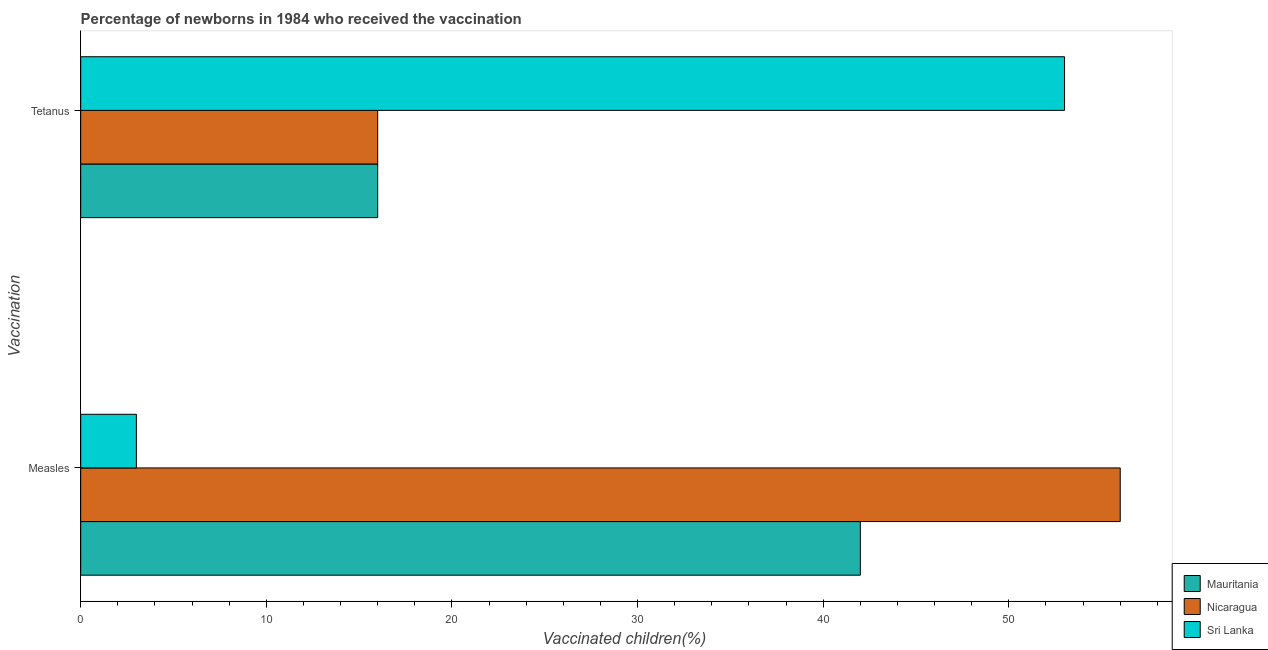How many different coloured bars are there?
Your answer should be very brief. 3. Are the number of bars on each tick of the Y-axis equal?
Provide a succinct answer. Yes. How many bars are there on the 1st tick from the top?
Keep it short and to the point. 3. What is the label of the 1st group of bars from the top?
Your response must be concise. Tetanus. What is the percentage of newborns who received vaccination for tetanus in Nicaragua?
Your response must be concise. 16. Across all countries, what is the maximum percentage of newborns who received vaccination for measles?
Provide a short and direct response. 56. Across all countries, what is the minimum percentage of newborns who received vaccination for tetanus?
Give a very brief answer. 16. In which country was the percentage of newborns who received vaccination for tetanus maximum?
Your response must be concise. Sri Lanka. In which country was the percentage of newborns who received vaccination for tetanus minimum?
Offer a very short reply. Mauritania. What is the total percentage of newborns who received vaccination for tetanus in the graph?
Ensure brevity in your answer.  85. What is the difference between the percentage of newborns who received vaccination for tetanus in Mauritania and that in Sri Lanka?
Offer a very short reply. -37. What is the difference between the percentage of newborns who received vaccination for tetanus in Mauritania and the percentage of newborns who received vaccination for measles in Nicaragua?
Offer a very short reply. -40. What is the average percentage of newborns who received vaccination for tetanus per country?
Your answer should be very brief. 28.33. What is the difference between the percentage of newborns who received vaccination for measles and percentage of newborns who received vaccination for tetanus in Sri Lanka?
Give a very brief answer. -50. What is the ratio of the percentage of newborns who received vaccination for tetanus in Sri Lanka to that in Mauritania?
Offer a very short reply. 3.31. Is the percentage of newborns who received vaccination for measles in Nicaragua less than that in Mauritania?
Your answer should be compact. No. In how many countries, is the percentage of newborns who received vaccination for tetanus greater than the average percentage of newborns who received vaccination for tetanus taken over all countries?
Provide a short and direct response. 1. What does the 2nd bar from the top in Measles represents?
Your answer should be compact. Nicaragua. What does the 2nd bar from the bottom in Measles represents?
Ensure brevity in your answer.  Nicaragua. How many bars are there?
Your answer should be very brief. 6. Are all the bars in the graph horizontal?
Keep it short and to the point. Yes. How many countries are there in the graph?
Make the answer very short. 3. Where does the legend appear in the graph?
Make the answer very short. Bottom right. How many legend labels are there?
Your response must be concise. 3. What is the title of the graph?
Give a very brief answer. Percentage of newborns in 1984 who received the vaccination. What is the label or title of the X-axis?
Provide a succinct answer. Vaccinated children(%)
. What is the label or title of the Y-axis?
Give a very brief answer. Vaccination. What is the Vaccinated children(%)
 in Mauritania in Measles?
Your response must be concise. 42. Across all Vaccination, what is the maximum Vaccinated children(%)
 of Mauritania?
Provide a succinct answer. 42. Across all Vaccination, what is the minimum Vaccinated children(%)
 of Sri Lanka?
Offer a very short reply. 3. What is the total Vaccinated children(%)
 of Mauritania in the graph?
Offer a very short reply. 58. What is the total Vaccinated children(%)
 in Nicaragua in the graph?
Provide a short and direct response. 72. What is the difference between the Vaccinated children(%)
 of Mauritania in Measles and that in Tetanus?
Keep it short and to the point. 26. What is the difference between the Vaccinated children(%)
 of Nicaragua in Measles and that in Tetanus?
Offer a terse response. 40. What is the difference between the Vaccinated children(%)
 in Sri Lanka in Measles and that in Tetanus?
Make the answer very short. -50. What is the difference between the Vaccinated children(%)
 in Mauritania in Measles and the Vaccinated children(%)
 in Sri Lanka in Tetanus?
Your answer should be very brief. -11. What is the average Vaccinated children(%)
 in Mauritania per Vaccination?
Make the answer very short. 29. What is the average Vaccinated children(%)
 of Sri Lanka per Vaccination?
Keep it short and to the point. 28. What is the difference between the Vaccinated children(%)
 in Mauritania and Vaccinated children(%)
 in Sri Lanka in Measles?
Make the answer very short. 39. What is the difference between the Vaccinated children(%)
 in Nicaragua and Vaccinated children(%)
 in Sri Lanka in Measles?
Your answer should be very brief. 53. What is the difference between the Vaccinated children(%)
 in Mauritania and Vaccinated children(%)
 in Sri Lanka in Tetanus?
Offer a very short reply. -37. What is the difference between the Vaccinated children(%)
 of Nicaragua and Vaccinated children(%)
 of Sri Lanka in Tetanus?
Offer a very short reply. -37. What is the ratio of the Vaccinated children(%)
 of Mauritania in Measles to that in Tetanus?
Your answer should be compact. 2.62. What is the ratio of the Vaccinated children(%)
 of Sri Lanka in Measles to that in Tetanus?
Offer a terse response. 0.06. What is the difference between the highest and the second highest Vaccinated children(%)
 of Mauritania?
Offer a very short reply. 26. What is the difference between the highest and the lowest Vaccinated children(%)
 of Mauritania?
Keep it short and to the point. 26. 